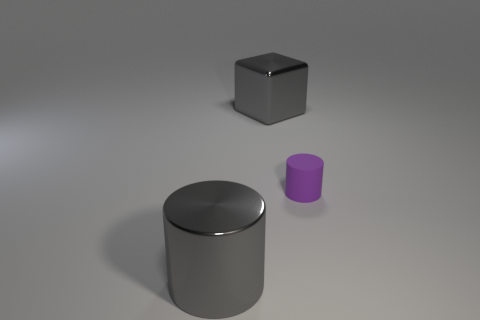Add 1 small rubber objects. How many objects exist? 4 Subtract all gray cylinders. How many cylinders are left? 1 Subtract all cylinders. How many objects are left? 1 Add 3 tiny purple rubber things. How many tiny purple rubber things exist? 4 Subtract 1 gray cylinders. How many objects are left? 2 Subtract 2 cylinders. How many cylinders are left? 0 Subtract all gray cylinders. Subtract all gray balls. How many cylinders are left? 1 Subtract all yellow blocks. How many gray cylinders are left? 1 Subtract all shiny cylinders. Subtract all big brown shiny blocks. How many objects are left? 2 Add 2 small cylinders. How many small cylinders are left? 3 